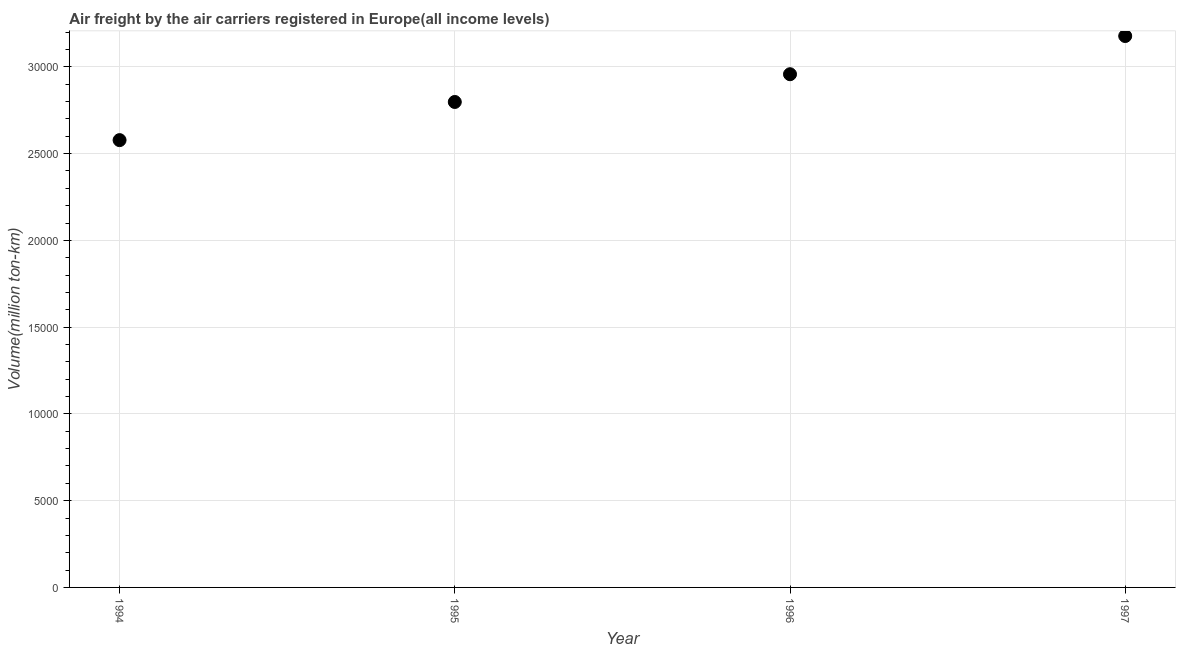What is the air freight in 1997?
Make the answer very short. 3.18e+04. Across all years, what is the maximum air freight?
Your response must be concise. 3.18e+04. Across all years, what is the minimum air freight?
Offer a very short reply. 2.58e+04. In which year was the air freight minimum?
Give a very brief answer. 1994. What is the sum of the air freight?
Your answer should be very brief. 1.15e+05. What is the difference between the air freight in 1994 and 1996?
Offer a very short reply. -3797.7. What is the average air freight per year?
Make the answer very short. 2.88e+04. What is the median air freight?
Offer a very short reply. 2.88e+04. In how many years, is the air freight greater than 29000 million ton-km?
Provide a short and direct response. 2. What is the ratio of the air freight in 1995 to that in 1996?
Offer a very short reply. 0.95. Is the air freight in 1994 less than that in 1996?
Make the answer very short. Yes. What is the difference between the highest and the second highest air freight?
Your response must be concise. 2201. What is the difference between the highest and the lowest air freight?
Offer a terse response. 5998.7. In how many years, is the air freight greater than the average air freight taken over all years?
Keep it short and to the point. 2. How many dotlines are there?
Ensure brevity in your answer.  1. How many years are there in the graph?
Your response must be concise. 4. What is the difference between two consecutive major ticks on the Y-axis?
Keep it short and to the point. 5000. Does the graph contain any zero values?
Offer a terse response. No. Does the graph contain grids?
Provide a short and direct response. Yes. What is the title of the graph?
Offer a very short reply. Air freight by the air carriers registered in Europe(all income levels). What is the label or title of the X-axis?
Your response must be concise. Year. What is the label or title of the Y-axis?
Make the answer very short. Volume(million ton-km). What is the Volume(million ton-km) in 1994?
Keep it short and to the point. 2.58e+04. What is the Volume(million ton-km) in 1995?
Your answer should be very brief. 2.80e+04. What is the Volume(million ton-km) in 1996?
Make the answer very short. 2.96e+04. What is the Volume(million ton-km) in 1997?
Your answer should be compact. 3.18e+04. What is the difference between the Volume(million ton-km) in 1994 and 1995?
Give a very brief answer. -2198.5. What is the difference between the Volume(million ton-km) in 1994 and 1996?
Provide a succinct answer. -3797.7. What is the difference between the Volume(million ton-km) in 1994 and 1997?
Your answer should be very brief. -5998.7. What is the difference between the Volume(million ton-km) in 1995 and 1996?
Provide a succinct answer. -1599.2. What is the difference between the Volume(million ton-km) in 1995 and 1997?
Ensure brevity in your answer.  -3800.2. What is the difference between the Volume(million ton-km) in 1996 and 1997?
Give a very brief answer. -2201. What is the ratio of the Volume(million ton-km) in 1994 to that in 1995?
Offer a terse response. 0.92. What is the ratio of the Volume(million ton-km) in 1994 to that in 1996?
Give a very brief answer. 0.87. What is the ratio of the Volume(million ton-km) in 1994 to that in 1997?
Provide a succinct answer. 0.81. What is the ratio of the Volume(million ton-km) in 1995 to that in 1996?
Provide a succinct answer. 0.95. What is the ratio of the Volume(million ton-km) in 1995 to that in 1997?
Your answer should be compact. 0.88. What is the ratio of the Volume(million ton-km) in 1996 to that in 1997?
Provide a short and direct response. 0.93. 